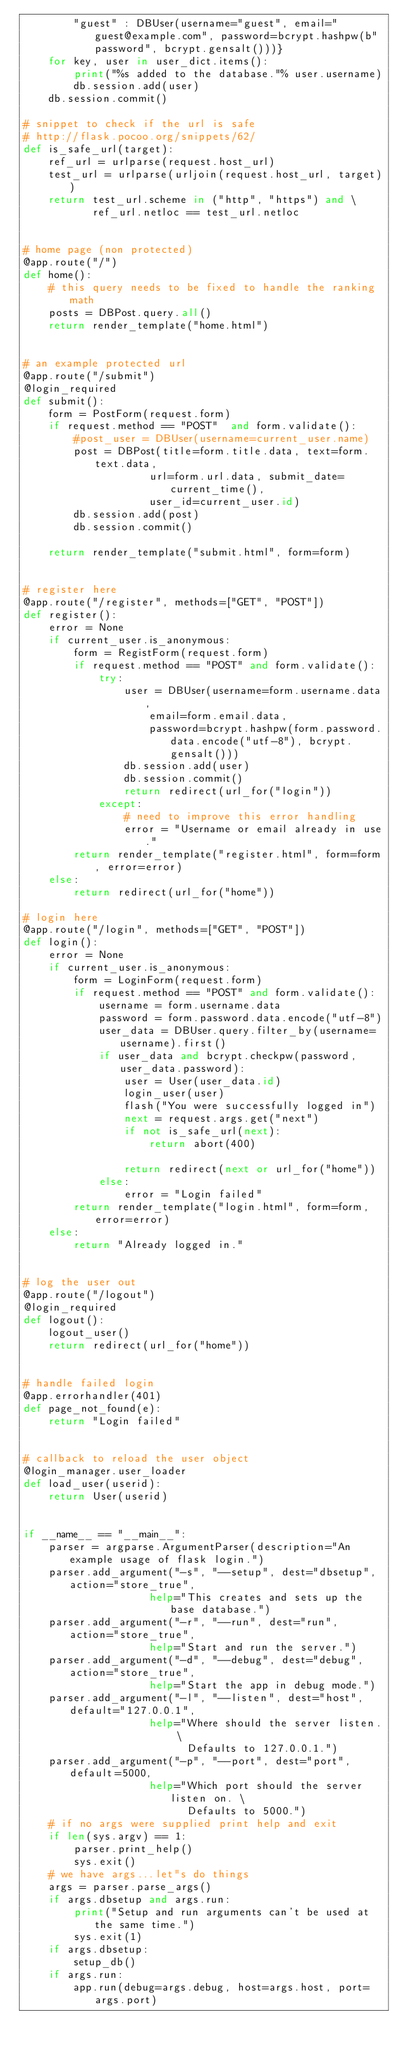Convert code to text. <code><loc_0><loc_0><loc_500><loc_500><_Python_>        "guest" : DBUser(username="guest", email="guest@example.com", password=bcrypt.hashpw(b"password", bcrypt.gensalt()))}
    for key, user in user_dict.items():
        print("%s added to the database."% user.username)
        db.session.add(user)
    db.session.commit()

# snippet to check if the url is safe
# http://flask.pocoo.org/snippets/62/
def is_safe_url(target):
    ref_url = urlparse(request.host_url)
    test_url = urlparse(urljoin(request.host_url, target))
    return test_url.scheme in ("http", "https") and \
           ref_url.netloc == test_url.netloc


# home page (non protected)
@app.route("/")
def home():
    # this query needs to be fixed to handle the ranking math
    posts = DBPost.query.all()
    return render_template("home.html")


# an example protected url
@app.route("/submit")
@login_required
def submit():
    form = PostForm(request.form)
    if request.method == "POST"  and form.validate():
        #post_user = DBUser(username=current_user.name)
        post = DBPost(title=form.title.data, text=form.text.data, 
                    url=form.url.data, submit_date=current_time(), 
                    user_id=current_user.id)
        db.session.add(post)
        db.session.commit()
    
    return render_template("submit.html", form=form)


# register here
@app.route("/register", methods=["GET", "POST"])
def register():
    error = None
    if current_user.is_anonymous:
        form = RegistForm(request.form)
        if request.method == "POST" and form.validate():
            try:
                user = DBUser(username=form.username.data, 
                    email=form.email.data, 
                    password=bcrypt.hashpw(form.password.data.encode("utf-8"), bcrypt.gensalt()))
                db.session.add(user)
                db.session.commit()
                return redirect(url_for("login"))
            except:
                # need to improve this error handling
                error = "Username or email already in use."
        return render_template("register.html", form=form, error=error)
    else:
        return redirect(url_for("home"))

# login here
@app.route("/login", methods=["GET", "POST"])
def login():
    error = None
    if current_user.is_anonymous:
        form = LoginForm(request.form)
        if request.method == "POST" and form.validate():
            username = form.username.data
            password = form.password.data.encode("utf-8")
            user_data = DBUser.query.filter_by(username=username).first()
            if user_data and bcrypt.checkpw(password, user_data.password):
                user = User(user_data.id)
                login_user(user)
                flash("You were successfully logged in")
                next = request.args.get("next")
                if not is_safe_url(next):
                    return abort(400)

                return redirect(next or url_for("home"))
            else:
                error = "Login failed"
        return render_template("login.html", form=form, error=error)
    else:
        return "Already logged in."


# log the user out
@app.route("/logout")
@login_required
def logout():
    logout_user()
    return redirect(url_for("home"))


# handle failed login
@app.errorhandler(401)
def page_not_found(e):
    return "Login failed"


# callback to reload the user object        
@login_manager.user_loader
def load_user(userid):
    return User(userid)


if __name__ == "__main__":
    parser = argparse.ArgumentParser(description="An example usage of flask login.")
    parser.add_argument("-s", "--setup", dest="dbsetup", action="store_true",
                    help="This creates and sets up the base database.")
    parser.add_argument("-r", "--run", dest="run",  action="store_true",
                    help="Start and run the server.")
    parser.add_argument("-d", "--debug", dest="debug",  action="store_true",
                    help="Start the app in debug mode.")
    parser.add_argument("-l", "--listen", dest="host", default="127.0.0.1",
                    help="Where should the server listen. \
                          Defaults to 127.0.0.1.")
    parser.add_argument("-p", "--port", dest="port", default=5000,
                    help="Which port should the server listen on. \
                          Defaults to 5000.")
    # if no args were supplied print help and exit
    if len(sys.argv) == 1:
        parser.print_help()
        sys.exit()
    # we have args...let"s do things
    args = parser.parse_args()
    if args.dbsetup and args.run:
        print("Setup and run arguments can't be used at the same time.")
        sys.exit(1)
    if args.dbsetup:
        setup_db()
    if args.run:
        app.run(debug=args.debug, host=args.host, port=args.port)</code> 